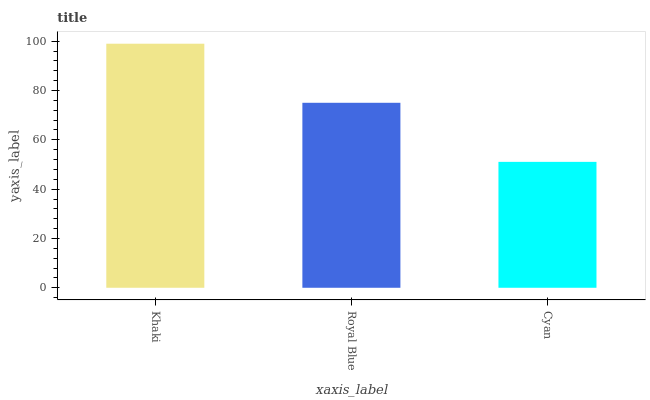Is Cyan the minimum?
Answer yes or no. Yes. Is Khaki the maximum?
Answer yes or no. Yes. Is Royal Blue the minimum?
Answer yes or no. No. Is Royal Blue the maximum?
Answer yes or no. No. Is Khaki greater than Royal Blue?
Answer yes or no. Yes. Is Royal Blue less than Khaki?
Answer yes or no. Yes. Is Royal Blue greater than Khaki?
Answer yes or no. No. Is Khaki less than Royal Blue?
Answer yes or no. No. Is Royal Blue the high median?
Answer yes or no. Yes. Is Royal Blue the low median?
Answer yes or no. Yes. Is Khaki the high median?
Answer yes or no. No. Is Cyan the low median?
Answer yes or no. No. 